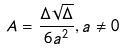Convert formula to latex. <formula><loc_0><loc_0><loc_500><loc_500>A = \frac { \Delta \sqrt { \Delta } } { 6 a ^ { 2 } } , a \ne 0</formula> 